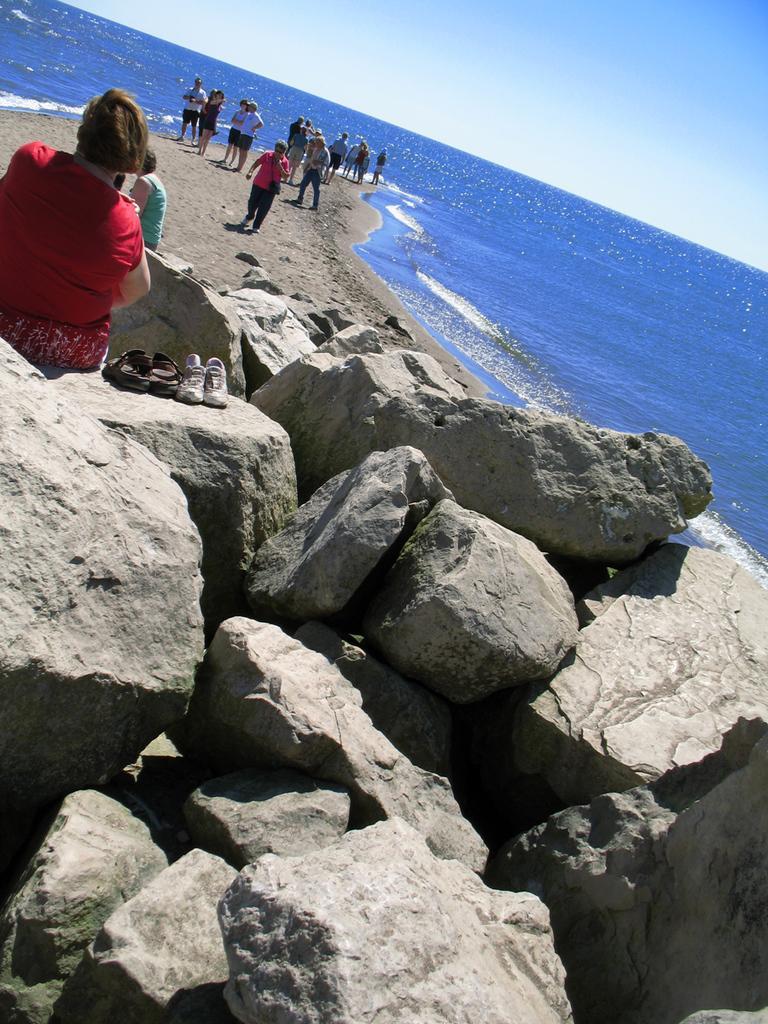Could you give a brief overview of what you see in this image? In this image we can see rocks and this person is sitting on it. Here we can see footwear, people standing on the sand, we can see water and the blue sky in the background. 